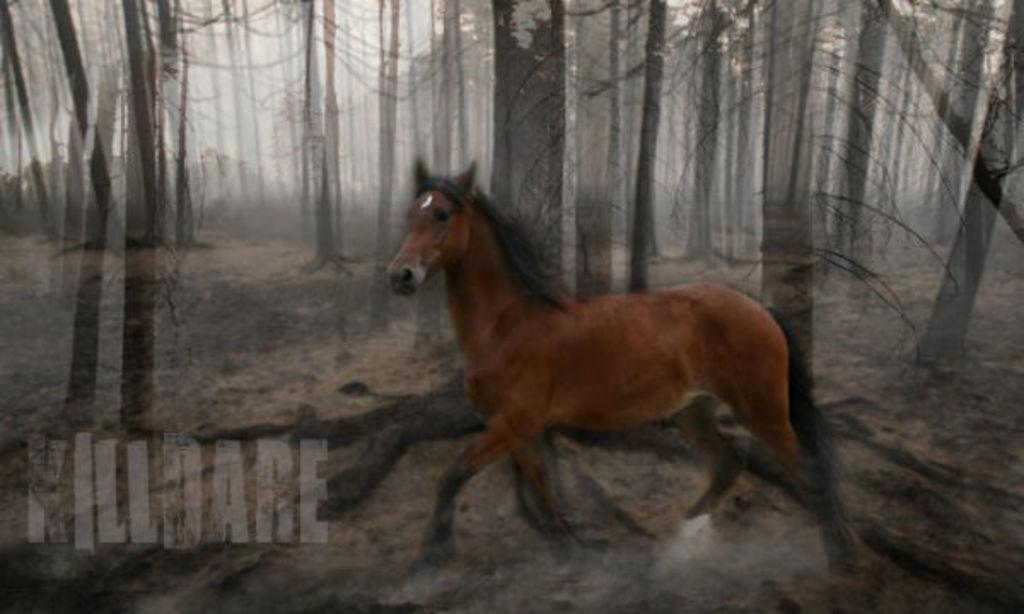What animal is present in the image? There is a horse in the image. What is the horse doing in the image? The horse is running in the image. What color is the horse? The horse is brown in color. What is visible at the bottom of the image? There is ground visible at the bottom of the image. What can be seen in the background of the image? There are trees in the background of the image. Who is the secretary assisting in the image? There is no secretary present in the image; it features a brown horse running on the ground with trees in the background. 